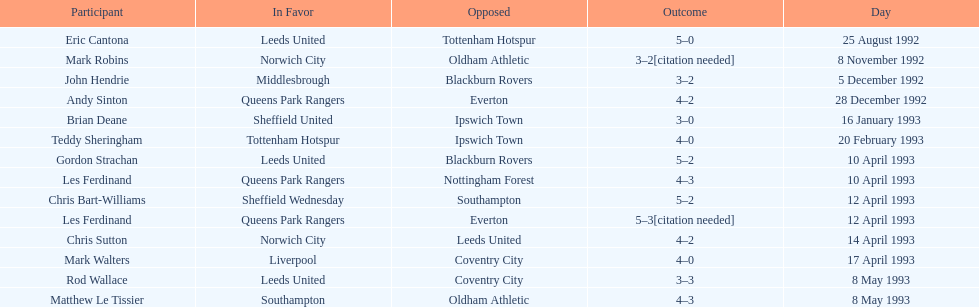Southampton played on may 8th, 1993, who was their opponent? Oldham Athletic. 